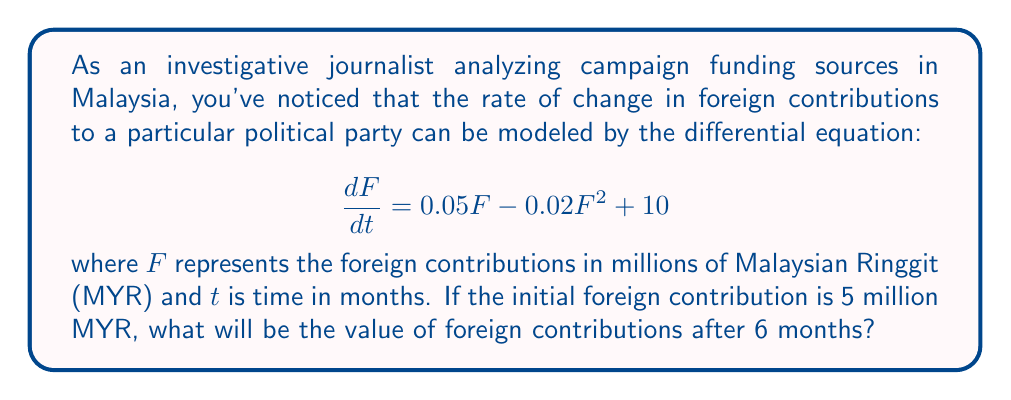Provide a solution to this math problem. To solve this problem, we need to use numerical methods as the differential equation is non-linear. We'll use the 4th-order Runge-Kutta method (RK4) to approximate the solution.

The given differential equation is:

$$\frac{dF}{dt} = 0.05F - 0.02F^2 + 10$$

With initial condition: $F(0) = 5$ million MYR

Let's define our function:
$$f(t, F) = 0.05F - 0.02F^2 + 10$$

The RK4 method uses the following formula to approximate the solution:

$$F_{n+1} = F_n + \frac{1}{6}(k_1 + 2k_2 + 2k_3 + k_4)$$

Where:
$$\begin{align*}
k_1 &= h \cdot f(t_n, F_n) \\
k_2 &= h \cdot f(t_n + \frac{h}{2}, F_n + \frac{k_1}{2}) \\
k_3 &= h \cdot f(t_n + \frac{h}{2}, F_n + \frac{k_2}{2}) \\
k_4 &= h \cdot f(t_n + h, F_n + k_3)
\end{align*}$$

We'll use a step size of $h = 1$ month and calculate for 6 steps.

Step 1 (t = 0 to t = 1):
$$\begin{align*}
k_1 &= 1 \cdot (0.05 \cdot 5 - 0.02 \cdot 5^2 + 10) = 10.75 \\
k_2 &= 1 \cdot (0.05 \cdot (5 + 5.375) - 0.02 \cdot (5 + 5.375)^2 + 10) = 10.4220 \\
k_3 &= 1 \cdot (0.05 \cdot (5 + 5.211) - 0.02 \cdot (5 + 5.211)^2 + 10) = 10.4537 \\
k_4 &= 1 \cdot (0.05 \cdot (5 + 10.4537) - 0.02 \cdot (5 + 10.4537)^2 + 10) = 9.7101
\end{align*}$$

$$F_1 = 5 + \frac{1}{6}(10.75 + 2 \cdot 10.4220 + 2 \cdot 10.4537 + 9.7101) = 15.4269$$

Continuing this process for the remaining 5 steps:

$$\begin{align*}
F_2 &= 24.5969 \\
F_3 &= 31.8803 \\
F_4 &= 37.3325 \\
F_5 &= 41.1800 \\
F_6 &= 43.7898
\end{align*}$$

Therefore, after 6 months, the foreign contributions will be approximately 43.7898 million MYR.
Answer: 43.7898 million MYR 